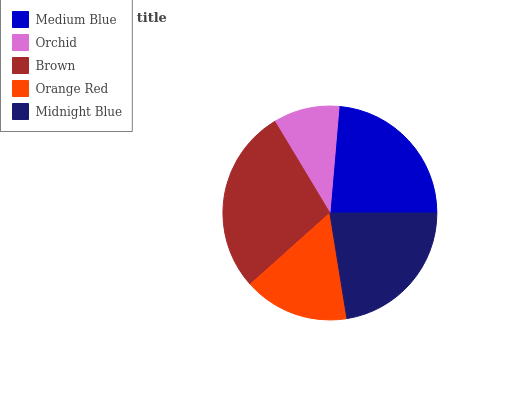Is Orchid the minimum?
Answer yes or no. Yes. Is Brown the maximum?
Answer yes or no. Yes. Is Brown the minimum?
Answer yes or no. No. Is Orchid the maximum?
Answer yes or no. No. Is Brown greater than Orchid?
Answer yes or no. Yes. Is Orchid less than Brown?
Answer yes or no. Yes. Is Orchid greater than Brown?
Answer yes or no. No. Is Brown less than Orchid?
Answer yes or no. No. Is Midnight Blue the high median?
Answer yes or no. Yes. Is Midnight Blue the low median?
Answer yes or no. Yes. Is Brown the high median?
Answer yes or no. No. Is Medium Blue the low median?
Answer yes or no. No. 